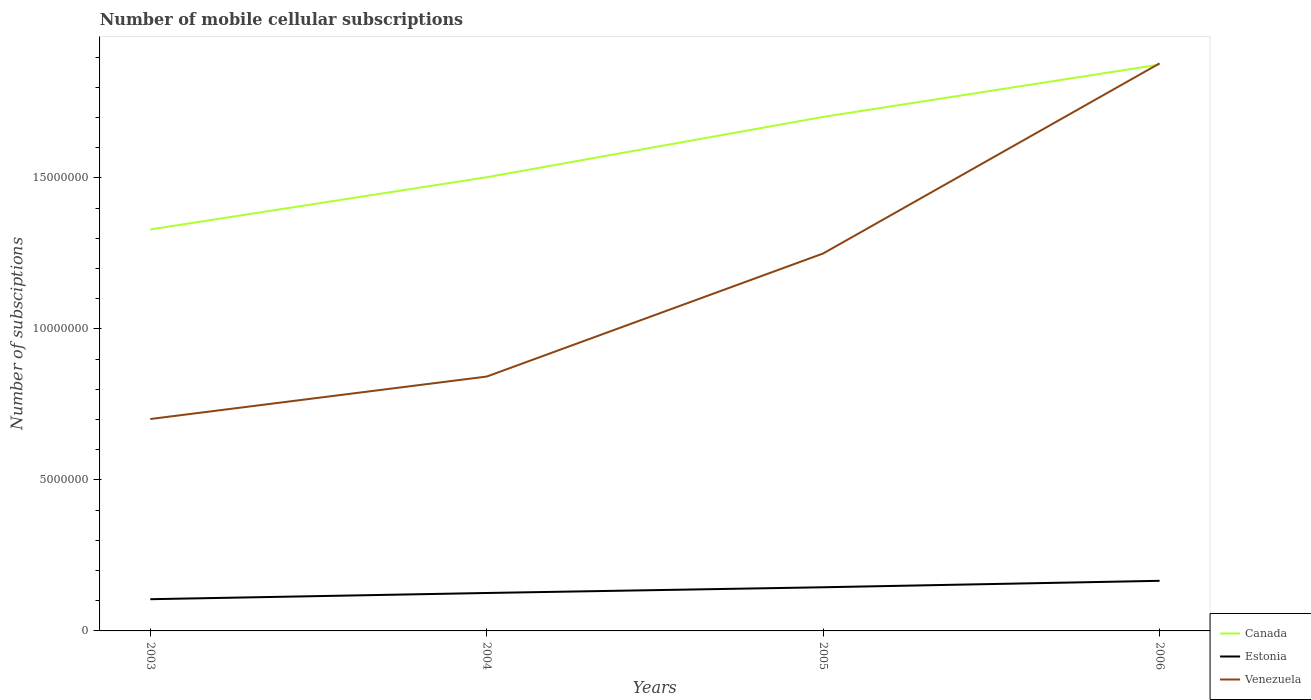Is the number of lines equal to the number of legend labels?
Your answer should be very brief. Yes. Across all years, what is the maximum number of mobile cellular subscriptions in Estonia?
Offer a terse response. 1.05e+06. What is the total number of mobile cellular subscriptions in Canada in the graph?
Offer a very short reply. -2.00e+06. What is the difference between the highest and the second highest number of mobile cellular subscriptions in Canada?
Offer a very short reply. 5.46e+06. Is the number of mobile cellular subscriptions in Venezuela strictly greater than the number of mobile cellular subscriptions in Canada over the years?
Offer a very short reply. No. How many years are there in the graph?
Provide a short and direct response. 4. Does the graph contain grids?
Your response must be concise. No. How many legend labels are there?
Offer a very short reply. 3. What is the title of the graph?
Offer a terse response. Number of mobile cellular subscriptions. Does "World" appear as one of the legend labels in the graph?
Ensure brevity in your answer.  No. What is the label or title of the Y-axis?
Make the answer very short. Number of subsciptions. What is the Number of subsciptions of Canada in 2003?
Keep it short and to the point. 1.33e+07. What is the Number of subsciptions of Estonia in 2003?
Offer a terse response. 1.05e+06. What is the Number of subsciptions of Venezuela in 2003?
Offer a terse response. 7.02e+06. What is the Number of subsciptions of Canada in 2004?
Offer a very short reply. 1.50e+07. What is the Number of subsciptions of Estonia in 2004?
Your answer should be very brief. 1.26e+06. What is the Number of subsciptions in Venezuela in 2004?
Your answer should be compact. 8.42e+06. What is the Number of subsciptions in Canada in 2005?
Provide a short and direct response. 1.70e+07. What is the Number of subsciptions of Estonia in 2005?
Make the answer very short. 1.45e+06. What is the Number of subsciptions in Venezuela in 2005?
Provide a succinct answer. 1.25e+07. What is the Number of subsciptions in Canada in 2006?
Ensure brevity in your answer.  1.87e+07. What is the Number of subsciptions in Estonia in 2006?
Provide a succinct answer. 1.66e+06. What is the Number of subsciptions in Venezuela in 2006?
Offer a very short reply. 1.88e+07. Across all years, what is the maximum Number of subsciptions of Canada?
Keep it short and to the point. 1.87e+07. Across all years, what is the maximum Number of subsciptions in Estonia?
Keep it short and to the point. 1.66e+06. Across all years, what is the maximum Number of subsciptions in Venezuela?
Your answer should be compact. 1.88e+07. Across all years, what is the minimum Number of subsciptions of Canada?
Make the answer very short. 1.33e+07. Across all years, what is the minimum Number of subsciptions of Estonia?
Offer a terse response. 1.05e+06. Across all years, what is the minimum Number of subsciptions of Venezuela?
Your answer should be very brief. 7.02e+06. What is the total Number of subsciptions of Canada in the graph?
Your answer should be very brief. 6.41e+07. What is the total Number of subsciptions of Estonia in the graph?
Ensure brevity in your answer.  5.41e+06. What is the total Number of subsciptions of Venezuela in the graph?
Your response must be concise. 4.67e+07. What is the difference between the Number of subsciptions in Canada in 2003 and that in 2004?
Provide a short and direct response. -1.73e+06. What is the difference between the Number of subsciptions in Estonia in 2003 and that in 2004?
Provide a succinct answer. -2.05e+05. What is the difference between the Number of subsciptions of Venezuela in 2003 and that in 2004?
Your answer should be compact. -1.41e+06. What is the difference between the Number of subsciptions in Canada in 2003 and that in 2005?
Make the answer very short. -3.73e+06. What is the difference between the Number of subsciptions in Estonia in 2003 and that in 2005?
Provide a short and direct response. -3.95e+05. What is the difference between the Number of subsciptions in Venezuela in 2003 and that in 2005?
Provide a succinct answer. -5.48e+06. What is the difference between the Number of subsciptions in Canada in 2003 and that in 2006?
Keep it short and to the point. -5.46e+06. What is the difference between the Number of subsciptions in Estonia in 2003 and that in 2006?
Ensure brevity in your answer.  -6.08e+05. What is the difference between the Number of subsciptions in Venezuela in 2003 and that in 2006?
Your answer should be compact. -1.18e+07. What is the difference between the Number of subsciptions in Canada in 2004 and that in 2005?
Make the answer very short. -2.00e+06. What is the difference between the Number of subsciptions in Estonia in 2004 and that in 2005?
Ensure brevity in your answer.  -1.90e+05. What is the difference between the Number of subsciptions of Venezuela in 2004 and that in 2005?
Offer a terse response. -4.07e+06. What is the difference between the Number of subsciptions in Canada in 2004 and that in 2006?
Your answer should be compact. -3.73e+06. What is the difference between the Number of subsciptions in Estonia in 2004 and that in 2006?
Ensure brevity in your answer.  -4.03e+05. What is the difference between the Number of subsciptions in Venezuela in 2004 and that in 2006?
Keep it short and to the point. -1.04e+07. What is the difference between the Number of subsciptions of Canada in 2005 and that in 2006?
Ensure brevity in your answer.  -1.73e+06. What is the difference between the Number of subsciptions in Estonia in 2005 and that in 2006?
Provide a succinct answer. -2.13e+05. What is the difference between the Number of subsciptions of Venezuela in 2005 and that in 2006?
Ensure brevity in your answer.  -6.29e+06. What is the difference between the Number of subsciptions in Canada in 2003 and the Number of subsciptions in Estonia in 2004?
Your answer should be compact. 1.20e+07. What is the difference between the Number of subsciptions in Canada in 2003 and the Number of subsciptions in Venezuela in 2004?
Offer a terse response. 4.87e+06. What is the difference between the Number of subsciptions in Estonia in 2003 and the Number of subsciptions in Venezuela in 2004?
Your answer should be very brief. -7.37e+06. What is the difference between the Number of subsciptions of Canada in 2003 and the Number of subsciptions of Estonia in 2005?
Give a very brief answer. 1.18e+07. What is the difference between the Number of subsciptions of Canada in 2003 and the Number of subsciptions of Venezuela in 2005?
Give a very brief answer. 7.95e+05. What is the difference between the Number of subsciptions in Estonia in 2003 and the Number of subsciptions in Venezuela in 2005?
Offer a terse response. -1.14e+07. What is the difference between the Number of subsciptions of Canada in 2003 and the Number of subsciptions of Estonia in 2006?
Make the answer very short. 1.16e+07. What is the difference between the Number of subsciptions of Canada in 2003 and the Number of subsciptions of Venezuela in 2006?
Your answer should be compact. -5.50e+06. What is the difference between the Number of subsciptions of Estonia in 2003 and the Number of subsciptions of Venezuela in 2006?
Your answer should be very brief. -1.77e+07. What is the difference between the Number of subsciptions in Canada in 2004 and the Number of subsciptions in Estonia in 2005?
Provide a succinct answer. 1.36e+07. What is the difference between the Number of subsciptions in Canada in 2004 and the Number of subsciptions in Venezuela in 2005?
Provide a succinct answer. 2.52e+06. What is the difference between the Number of subsciptions in Estonia in 2004 and the Number of subsciptions in Venezuela in 2005?
Provide a succinct answer. -1.12e+07. What is the difference between the Number of subsciptions in Canada in 2004 and the Number of subsciptions in Estonia in 2006?
Keep it short and to the point. 1.34e+07. What is the difference between the Number of subsciptions of Canada in 2004 and the Number of subsciptions of Venezuela in 2006?
Keep it short and to the point. -3.77e+06. What is the difference between the Number of subsciptions in Estonia in 2004 and the Number of subsciptions in Venezuela in 2006?
Your answer should be compact. -1.75e+07. What is the difference between the Number of subsciptions of Canada in 2005 and the Number of subsciptions of Estonia in 2006?
Your answer should be compact. 1.54e+07. What is the difference between the Number of subsciptions of Canada in 2005 and the Number of subsciptions of Venezuela in 2006?
Offer a terse response. -1.77e+06. What is the difference between the Number of subsciptions of Estonia in 2005 and the Number of subsciptions of Venezuela in 2006?
Your answer should be very brief. -1.73e+07. What is the average Number of subsciptions of Canada per year?
Provide a short and direct response. 1.60e+07. What is the average Number of subsciptions in Estonia per year?
Offer a terse response. 1.35e+06. What is the average Number of subsciptions in Venezuela per year?
Offer a very short reply. 1.17e+07. In the year 2003, what is the difference between the Number of subsciptions of Canada and Number of subsciptions of Estonia?
Offer a terse response. 1.22e+07. In the year 2003, what is the difference between the Number of subsciptions of Canada and Number of subsciptions of Venezuela?
Your response must be concise. 6.28e+06. In the year 2003, what is the difference between the Number of subsciptions in Estonia and Number of subsciptions in Venezuela?
Provide a succinct answer. -5.96e+06. In the year 2004, what is the difference between the Number of subsciptions of Canada and Number of subsciptions of Estonia?
Make the answer very short. 1.38e+07. In the year 2004, what is the difference between the Number of subsciptions in Canada and Number of subsciptions in Venezuela?
Make the answer very short. 6.60e+06. In the year 2004, what is the difference between the Number of subsciptions of Estonia and Number of subsciptions of Venezuela?
Give a very brief answer. -7.17e+06. In the year 2005, what is the difference between the Number of subsciptions of Canada and Number of subsciptions of Estonia?
Your response must be concise. 1.56e+07. In the year 2005, what is the difference between the Number of subsciptions of Canada and Number of subsciptions of Venezuela?
Provide a succinct answer. 4.52e+06. In the year 2005, what is the difference between the Number of subsciptions of Estonia and Number of subsciptions of Venezuela?
Give a very brief answer. -1.11e+07. In the year 2006, what is the difference between the Number of subsciptions of Canada and Number of subsciptions of Estonia?
Provide a succinct answer. 1.71e+07. In the year 2006, what is the difference between the Number of subsciptions of Canada and Number of subsciptions of Venezuela?
Ensure brevity in your answer.  -4.04e+04. In the year 2006, what is the difference between the Number of subsciptions in Estonia and Number of subsciptions in Venezuela?
Offer a very short reply. -1.71e+07. What is the ratio of the Number of subsciptions in Canada in 2003 to that in 2004?
Provide a short and direct response. 0.88. What is the ratio of the Number of subsciptions in Estonia in 2003 to that in 2004?
Make the answer very short. 0.84. What is the ratio of the Number of subsciptions of Venezuela in 2003 to that in 2004?
Make the answer very short. 0.83. What is the ratio of the Number of subsciptions of Canada in 2003 to that in 2005?
Give a very brief answer. 0.78. What is the ratio of the Number of subsciptions of Estonia in 2003 to that in 2005?
Your answer should be very brief. 0.73. What is the ratio of the Number of subsciptions in Venezuela in 2003 to that in 2005?
Give a very brief answer. 0.56. What is the ratio of the Number of subsciptions in Canada in 2003 to that in 2006?
Keep it short and to the point. 0.71. What is the ratio of the Number of subsciptions in Estonia in 2003 to that in 2006?
Your answer should be very brief. 0.63. What is the ratio of the Number of subsciptions in Venezuela in 2003 to that in 2006?
Give a very brief answer. 0.37. What is the ratio of the Number of subsciptions in Canada in 2004 to that in 2005?
Give a very brief answer. 0.88. What is the ratio of the Number of subsciptions of Estonia in 2004 to that in 2005?
Offer a terse response. 0.87. What is the ratio of the Number of subsciptions in Venezuela in 2004 to that in 2005?
Make the answer very short. 0.67. What is the ratio of the Number of subsciptions in Canada in 2004 to that in 2006?
Make the answer very short. 0.8. What is the ratio of the Number of subsciptions in Estonia in 2004 to that in 2006?
Your answer should be very brief. 0.76. What is the ratio of the Number of subsciptions in Venezuela in 2004 to that in 2006?
Your response must be concise. 0.45. What is the ratio of the Number of subsciptions in Canada in 2005 to that in 2006?
Your response must be concise. 0.91. What is the ratio of the Number of subsciptions of Estonia in 2005 to that in 2006?
Give a very brief answer. 0.87. What is the ratio of the Number of subsciptions of Venezuela in 2005 to that in 2006?
Offer a very short reply. 0.67. What is the difference between the highest and the second highest Number of subsciptions in Canada?
Make the answer very short. 1.73e+06. What is the difference between the highest and the second highest Number of subsciptions of Estonia?
Provide a short and direct response. 2.13e+05. What is the difference between the highest and the second highest Number of subsciptions of Venezuela?
Your answer should be very brief. 6.29e+06. What is the difference between the highest and the lowest Number of subsciptions in Canada?
Your response must be concise. 5.46e+06. What is the difference between the highest and the lowest Number of subsciptions of Estonia?
Provide a short and direct response. 6.08e+05. What is the difference between the highest and the lowest Number of subsciptions of Venezuela?
Ensure brevity in your answer.  1.18e+07. 